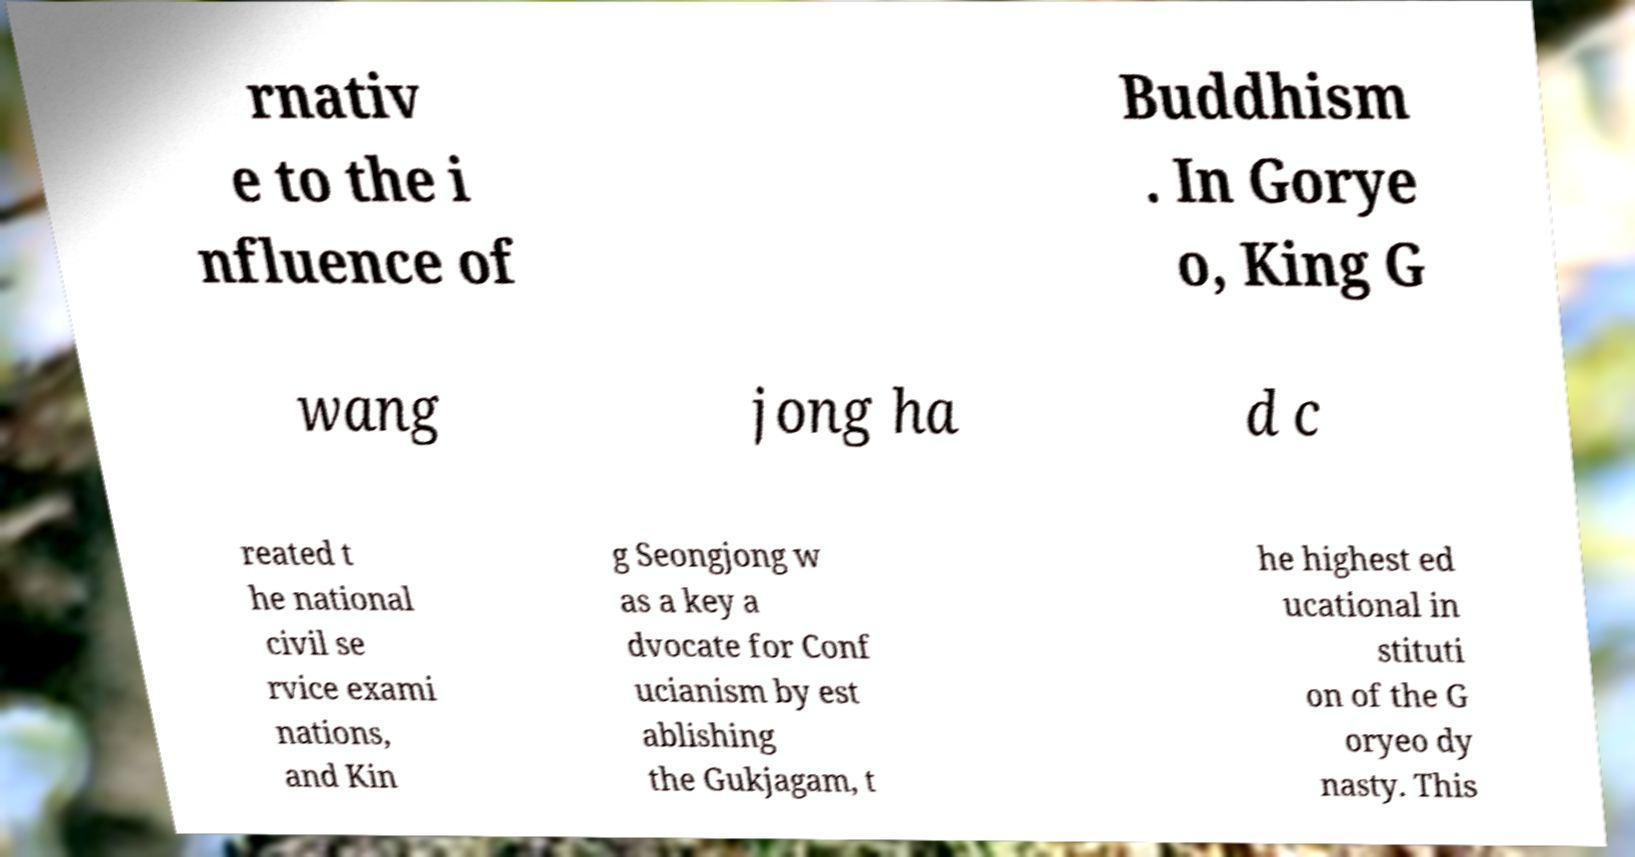Can you accurately transcribe the text from the provided image for me? rnativ e to the i nfluence of Buddhism . In Gorye o, King G wang jong ha d c reated t he national civil se rvice exami nations, and Kin g Seongjong w as a key a dvocate for Conf ucianism by est ablishing the Gukjagam, t he highest ed ucational in stituti on of the G oryeo dy nasty. This 